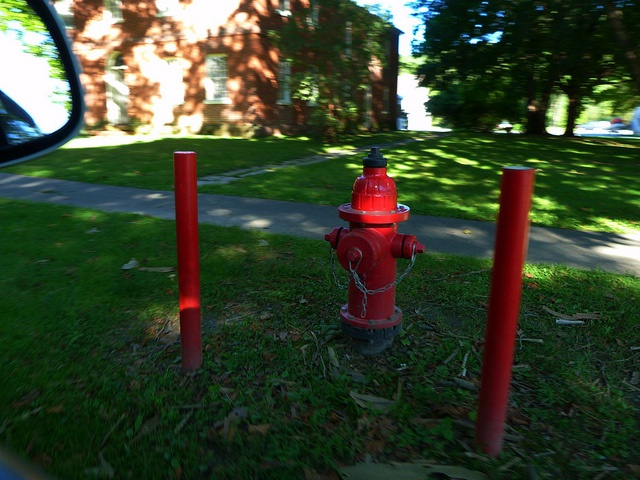Describe the objects in this image and their specific colors. I can see a fire hydrant in lime, maroon, black, red, and brown tones in this image. 